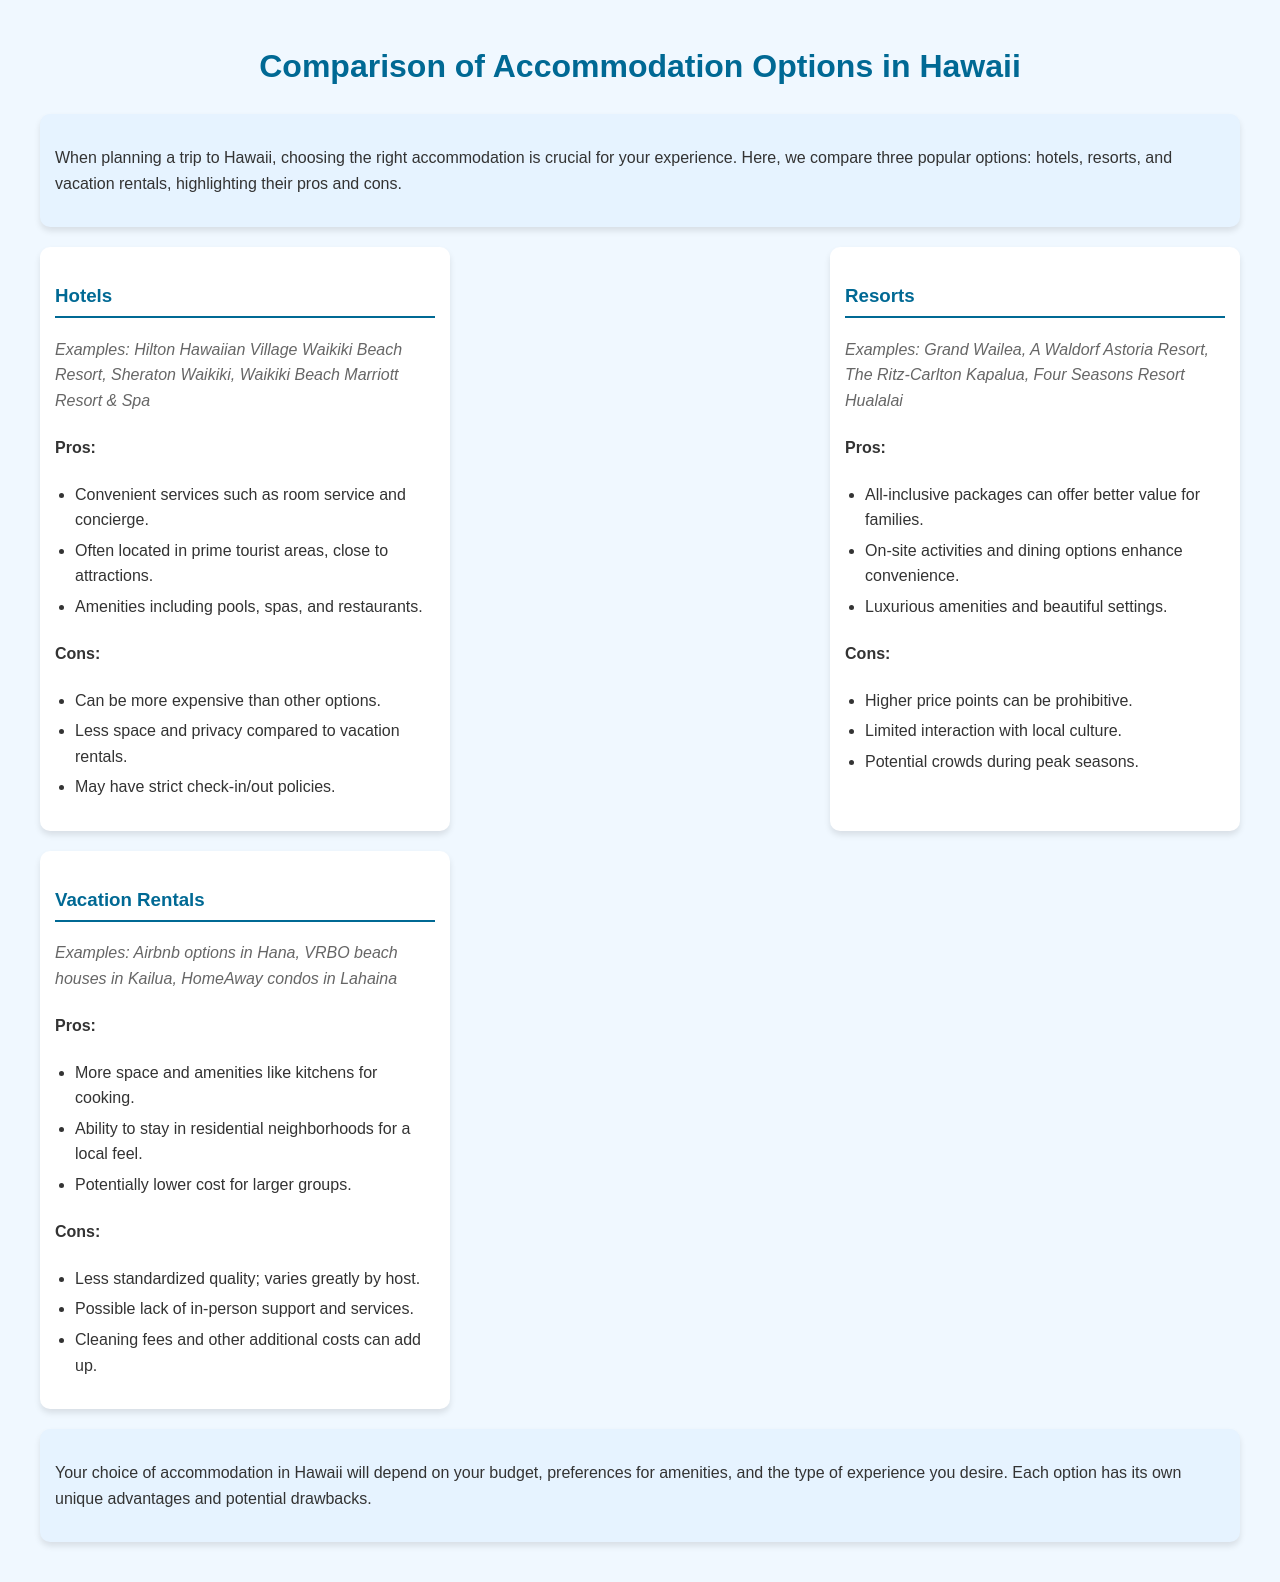What are examples of hotels in Hawaii? The document lists specific hotels such as Hilton Hawaiian Village Waikiki Beach Resort, Sheraton Waikiki, and Waikiki Beach Marriott Resort & Spa as examples of hotels in Hawaii.
Answer: Hilton Hawaiian Village Waikiki Beach Resort, Sheraton Waikiki, Waikiki Beach Marriott Resort & Spa What is a key advantage of resorts? Resorts offer all-inclusive packages which provide better value for families.
Answer: All-inclusive packages What is a disadvantage of vacation rentals? The document notes that a disadvantage of vacation rentals is the less standardized quality, which varies greatly by host.
Answer: Less standardized quality What are examples of vacation rentals in Hawaii? The document provides examples such as Airbnb options in Hana, VRBO beach houses in Kailua, and HomeAway condos in Lahaina.
Answer: Airbnb options in Hana, VRBO beach houses in Kailua, HomeAway condos in Lahaina What is a common feature of hotels? Hotels typically offer convenient services such as room service and concierge.
Answer: Room service and concierge What type of accommodation may have higher price points? The document indicates that resorts typically have higher price points, which can be prohibitive.
Answer: Resorts What is a trait of vacation rentals regarding location? Vacation rentals allow guests to stay in residential neighborhoods for a local feel.
Answer: Stay in residential neighborhoods What is a potential downside of resorts during peak seasons? The document mentions that resorts may have potential crowds during peak seasons.
Answer: Potential crowds What is a reason someone might choose vacation rentals over hotels? Vacation rentals provide more space and amenities like kitchens for cooking.
Answer: More space and amenities 